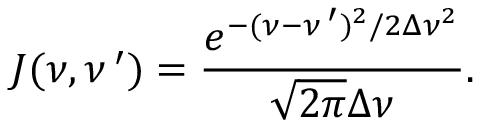<formula> <loc_0><loc_0><loc_500><loc_500>J ( \nu , \nu \, ^ { \prime } ) = \frac { e ^ { - ( \nu - \nu \, ^ { \prime } ) ^ { 2 } / 2 \Delta \nu ^ { 2 } } } { \sqrt { 2 \pi } \Delta \nu } .</formula> 